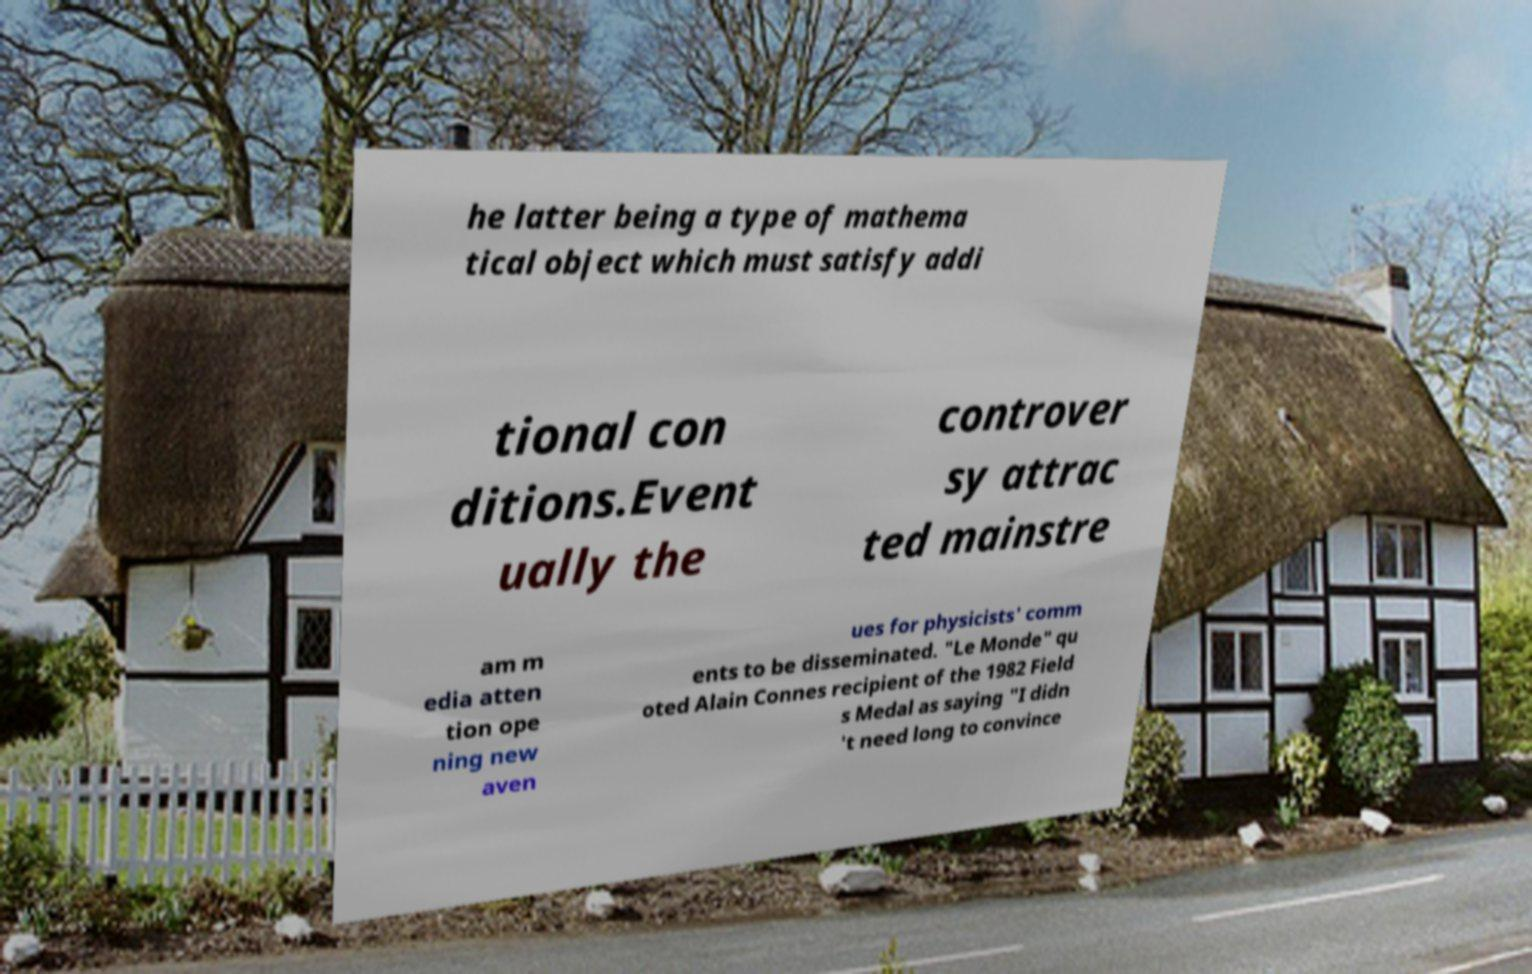There's text embedded in this image that I need extracted. Can you transcribe it verbatim? he latter being a type of mathema tical object which must satisfy addi tional con ditions.Event ually the controver sy attrac ted mainstre am m edia atten tion ope ning new aven ues for physicists' comm ents to be disseminated. "Le Monde" qu oted Alain Connes recipient of the 1982 Field s Medal as saying "I didn 't need long to convince 